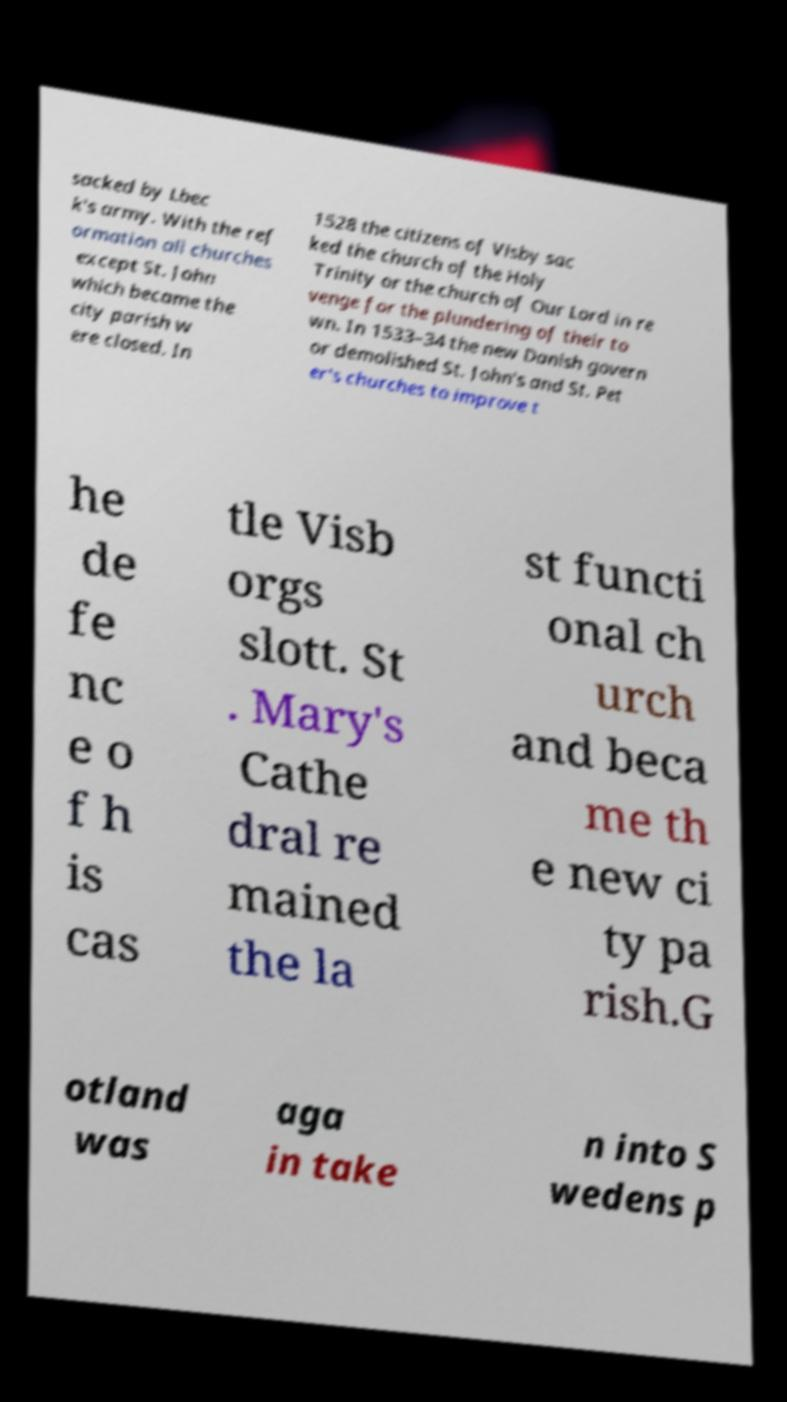Can you read and provide the text displayed in the image?This photo seems to have some interesting text. Can you extract and type it out for me? sacked by Lbec k's army. With the ref ormation all churches except St. John which became the city parish w ere closed. In 1528 the citizens of Visby sac ked the church of the Holy Trinity or the church of Our Lord in re venge for the plundering of their to wn. In 1533–34 the new Danish govern or demolished St. John's and St. Pet er's churches to improve t he de fe nc e o f h is cas tle Visb orgs slott. St . Mary's Cathe dral re mained the la st functi onal ch urch and beca me th e new ci ty pa rish.G otland was aga in take n into S wedens p 